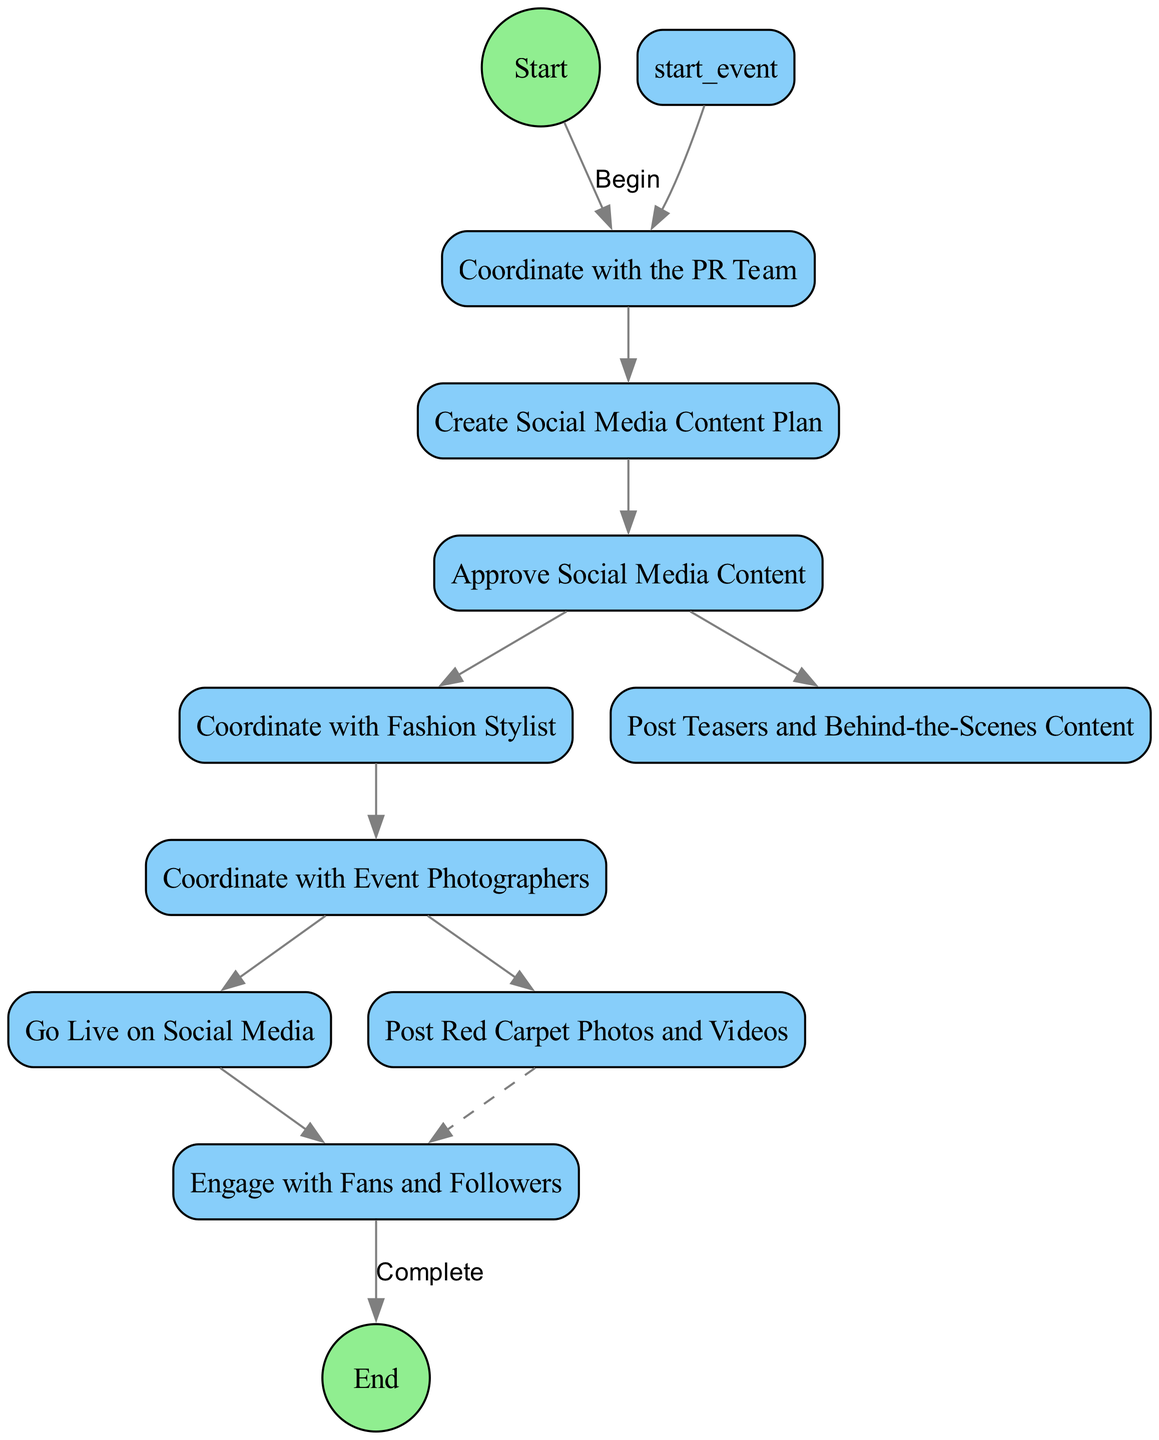What is the start event in the diagram? The start event indicated in the diagram is "Prepare for Red Carpet Event." This can be identified as the node connected to the first activity in the flow.
Answer: Prepare for Red Carpet Event How many activities are listed in the diagram? The diagram contains a total of 9 activities, which can be counted from the list provided in the data. Each activity is represented as a unique node.
Answer: 9 Which activity follows "Create Social Media Content Plan"? The activity that follows "Create Social Media Content Plan" is "Approve Social Media Content." This is determined by looking at the arrows connecting the nodes in the flow.
Answer: Approve Social Media Content What are the last two activities before reaching the end event? The last two activities before the end event are "Post Red Carpet Photos and Videos" and "Engage with Fans and Followers." These are the two activities directly connected to the end event node and are the last steps in the process flow.
Answer: Post Red Carpet Photos and Videos, Engage with Fans and Followers What is the alternative predecessor for "Engage with Fans and Followers"? The alternative predecessor for "Engage with Fans and Followers" is "Post Red Carpet Photos and Videos." This is specified in the alternative pathway for this activity, indicating that it can be reached through either of two activities.
Answer: Post Red Carpet Photos and Videos What is the relationship between "Coordinate with Fashion Stylist" and "Post Teasers and Behind-the-Scenes Content"? "Coordinate with Fashion Stylist" is sequentially after "Approve Social Media Content," while "Post Teasers and Behind-the-Scenes Content" branches out of the same preceding activity. They both are connected to "Approve Social Media Content," but do not directly relate to each other.
Answer: No direct relationship Which activity involves going live on social media? The activity that involves going live on social media is "Go Live on Social Media." It is directly after coordinating with event photographers, indicating its placement in the sequence of actions.
Answer: Go Live on Social Media What is the end event of the diagram? The end event of the diagram is titled "Complete Red Carpet Social Media Activities." This is denoted as the final node before the end of the activity flow.
Answer: Complete Red Carpet Social Media Activities 